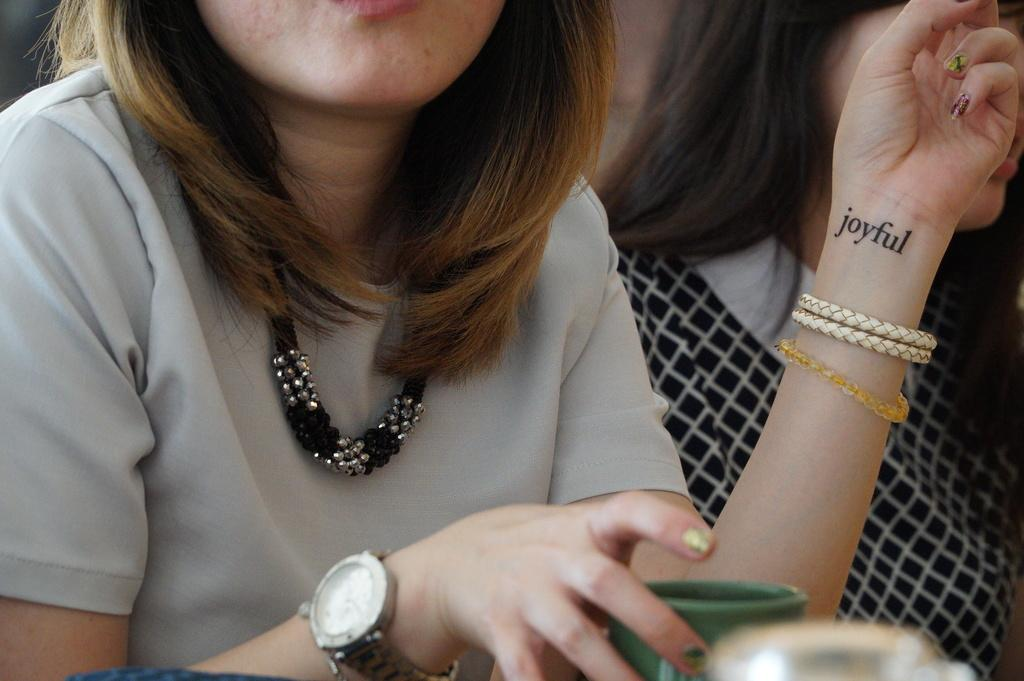<image>
Offer a succinct explanation of the picture presented. Women with a necklace and a tattoo on her wrist saying joyful. 